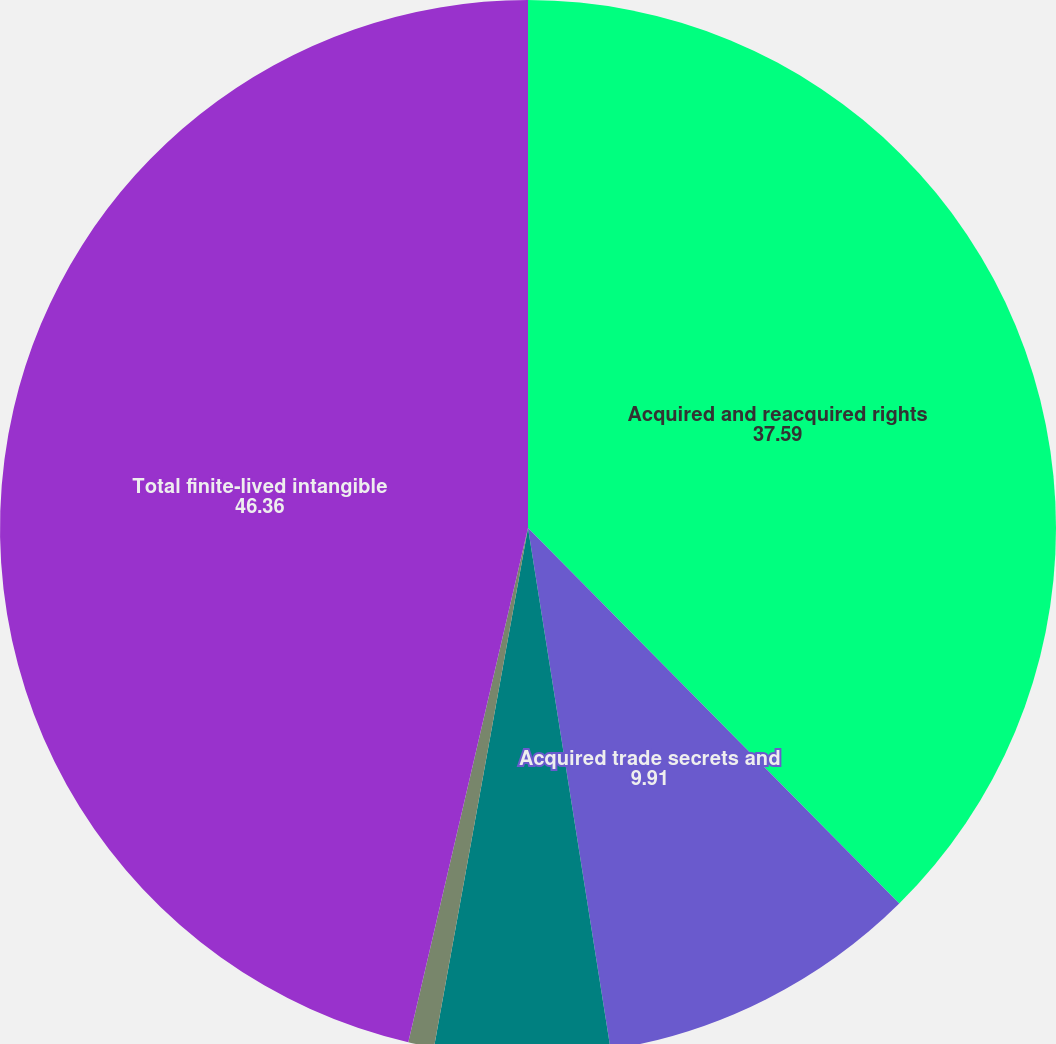Convert chart. <chart><loc_0><loc_0><loc_500><loc_500><pie_chart><fcel>Acquired and reacquired rights<fcel>Acquired trade secrets and<fcel>Trade names trademarks and<fcel>Other finite-lived intangible<fcel>Total finite-lived intangible<nl><fcel>37.59%<fcel>9.91%<fcel>5.35%<fcel>0.79%<fcel>46.36%<nl></chart> 